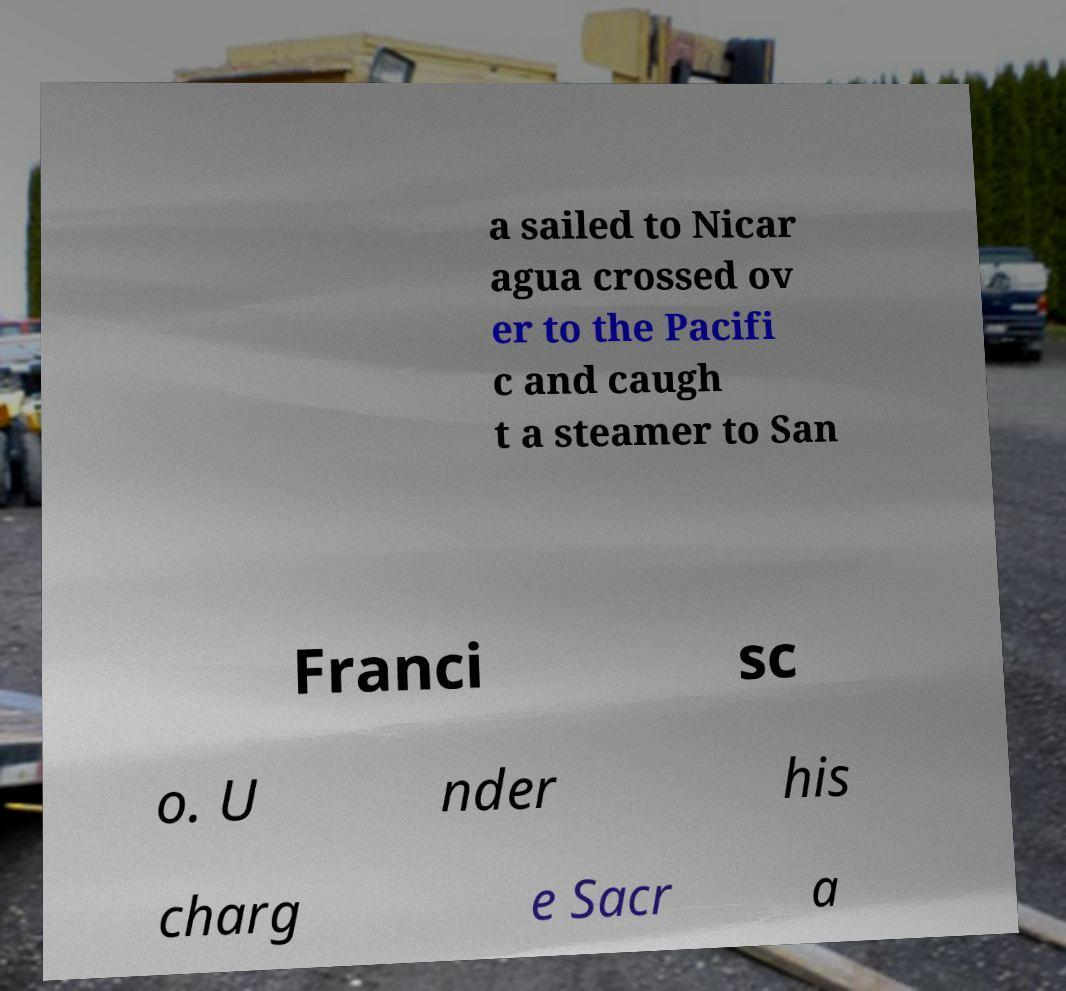Could you assist in decoding the text presented in this image and type it out clearly? a sailed to Nicar agua crossed ov er to the Pacifi c and caugh t a steamer to San Franci sc o. U nder his charg e Sacr a 